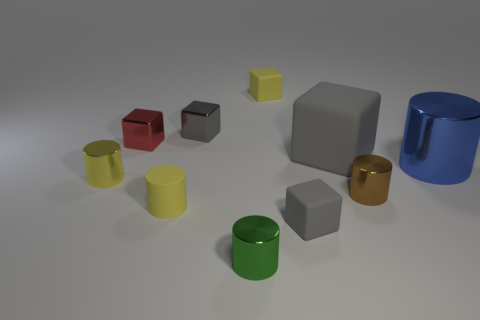The tiny matte block in front of the matte block behind the tiny gray block that is behind the tiny red metallic block is what color?
Offer a very short reply. Gray. Is the color of the big shiny cylinder the same as the small matte cylinder?
Give a very brief answer. No. How many things are behind the tiny yellow rubber cylinder and left of the big blue cylinder?
Offer a very short reply. 6. What number of metal things are small purple cylinders or green things?
Provide a succinct answer. 1. What is the large thing left of the small cylinder that is right of the green cylinder made of?
Ensure brevity in your answer.  Rubber. The tiny matte thing that is the same color as the large block is what shape?
Provide a short and direct response. Cube. There is a gray metal thing that is the same size as the rubber cylinder; what is its shape?
Provide a succinct answer. Cube. Are there fewer big gray metallic blocks than small yellow rubber blocks?
Your response must be concise. Yes. Are there any tiny yellow shiny things on the right side of the yellow matte thing that is in front of the large cube?
Your answer should be compact. No. What is the shape of the small yellow thing that is the same material as the small yellow block?
Provide a succinct answer. Cylinder. 